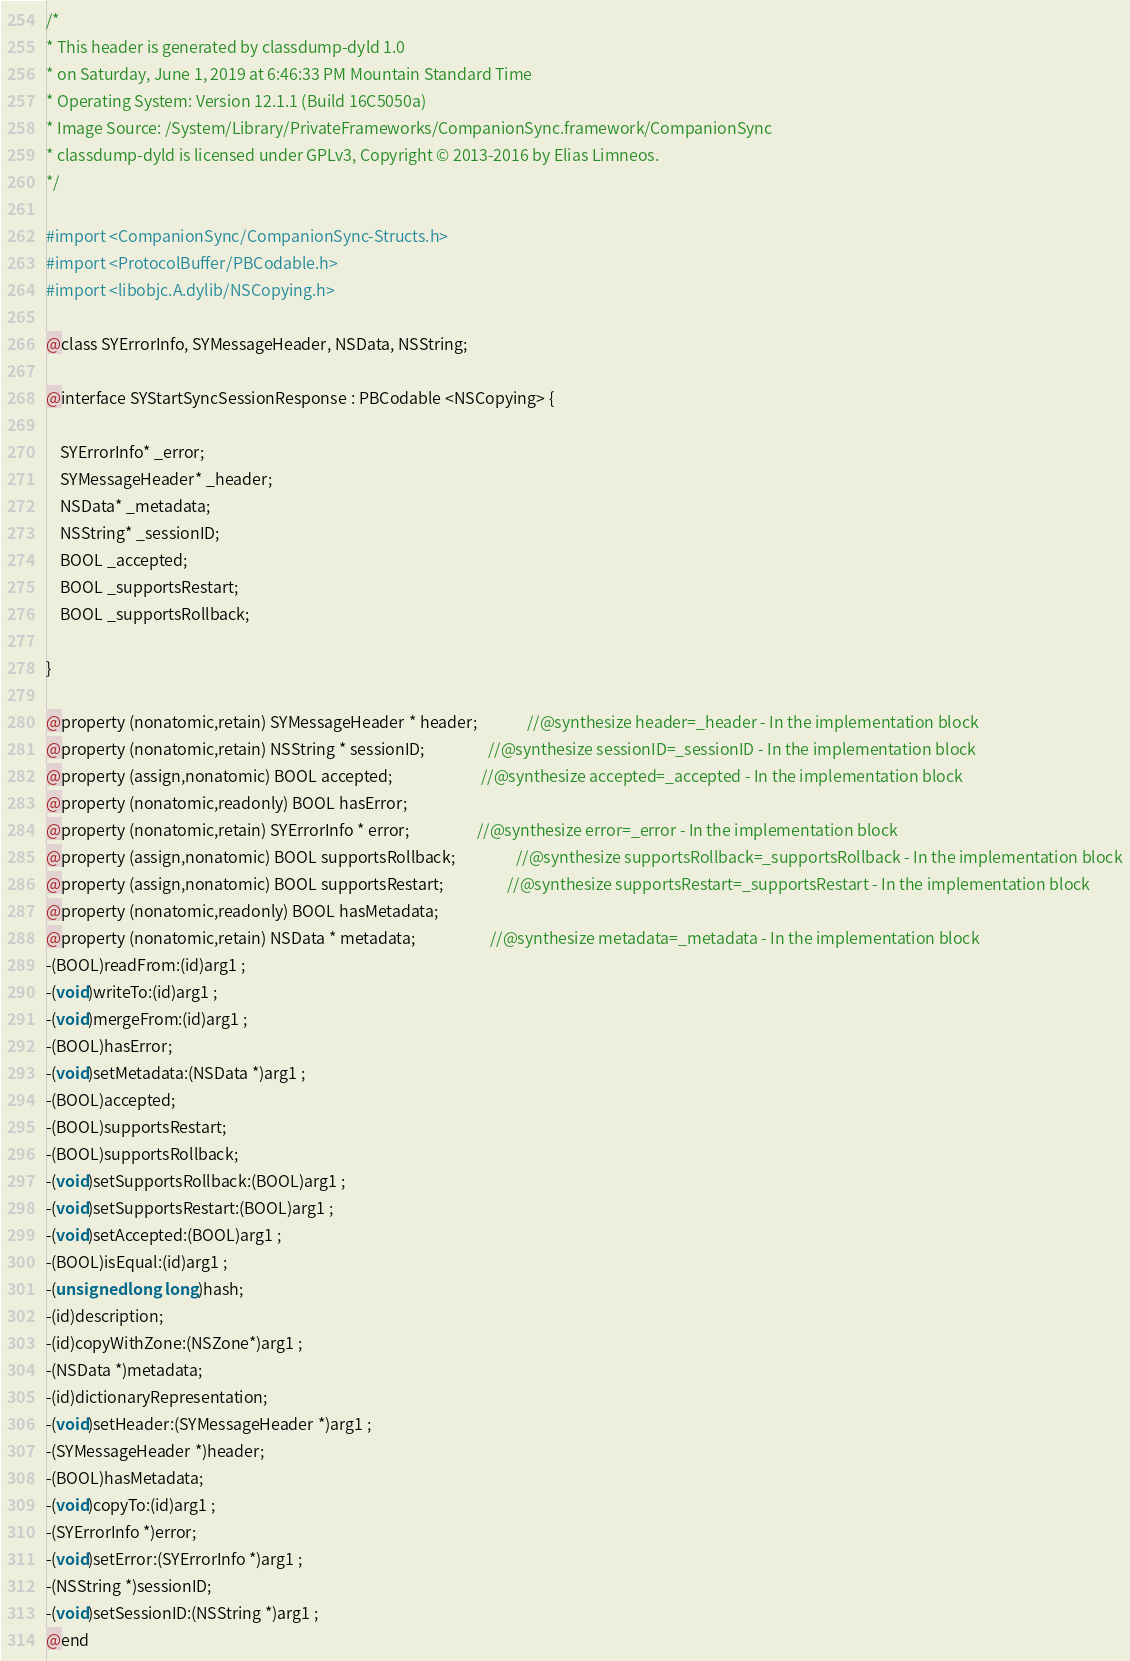Convert code to text. <code><loc_0><loc_0><loc_500><loc_500><_C_>/*
* This header is generated by classdump-dyld 1.0
* on Saturday, June 1, 2019 at 6:46:33 PM Mountain Standard Time
* Operating System: Version 12.1.1 (Build 16C5050a)
* Image Source: /System/Library/PrivateFrameworks/CompanionSync.framework/CompanionSync
* classdump-dyld is licensed under GPLv3, Copyright © 2013-2016 by Elias Limneos.
*/

#import <CompanionSync/CompanionSync-Structs.h>
#import <ProtocolBuffer/PBCodable.h>
#import <libobjc.A.dylib/NSCopying.h>

@class SYErrorInfo, SYMessageHeader, NSData, NSString;

@interface SYStartSyncSessionResponse : PBCodable <NSCopying> {

	SYErrorInfo* _error;
	SYMessageHeader* _header;
	NSData* _metadata;
	NSString* _sessionID;
	BOOL _accepted;
	BOOL _supportsRestart;
	BOOL _supportsRollback;

}

@property (nonatomic,retain) SYMessageHeader * header;              //@synthesize header=_header - In the implementation block
@property (nonatomic,retain) NSString * sessionID;                  //@synthesize sessionID=_sessionID - In the implementation block
@property (assign,nonatomic) BOOL accepted;                         //@synthesize accepted=_accepted - In the implementation block
@property (nonatomic,readonly) BOOL hasError; 
@property (nonatomic,retain) SYErrorInfo * error;                   //@synthesize error=_error - In the implementation block
@property (assign,nonatomic) BOOL supportsRollback;                 //@synthesize supportsRollback=_supportsRollback - In the implementation block
@property (assign,nonatomic) BOOL supportsRestart;                  //@synthesize supportsRestart=_supportsRestart - In the implementation block
@property (nonatomic,readonly) BOOL hasMetadata; 
@property (nonatomic,retain) NSData * metadata;                     //@synthesize metadata=_metadata - In the implementation block
-(BOOL)readFrom:(id)arg1 ;
-(void)writeTo:(id)arg1 ;
-(void)mergeFrom:(id)arg1 ;
-(BOOL)hasError;
-(void)setMetadata:(NSData *)arg1 ;
-(BOOL)accepted;
-(BOOL)supportsRestart;
-(BOOL)supportsRollback;
-(void)setSupportsRollback:(BOOL)arg1 ;
-(void)setSupportsRestart:(BOOL)arg1 ;
-(void)setAccepted:(BOOL)arg1 ;
-(BOOL)isEqual:(id)arg1 ;
-(unsigned long long)hash;
-(id)description;
-(id)copyWithZone:(NSZone*)arg1 ;
-(NSData *)metadata;
-(id)dictionaryRepresentation;
-(void)setHeader:(SYMessageHeader *)arg1 ;
-(SYMessageHeader *)header;
-(BOOL)hasMetadata;
-(void)copyTo:(id)arg1 ;
-(SYErrorInfo *)error;
-(void)setError:(SYErrorInfo *)arg1 ;
-(NSString *)sessionID;
-(void)setSessionID:(NSString *)arg1 ;
@end

</code> 